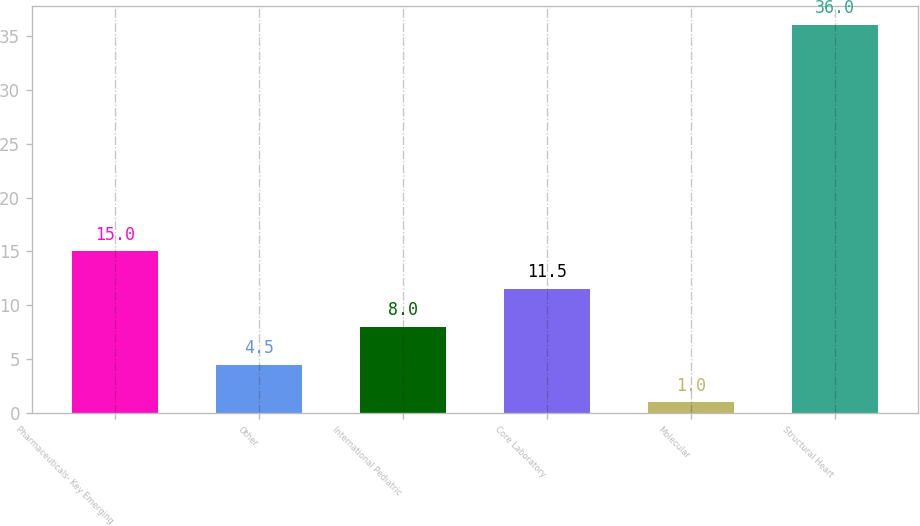<chart> <loc_0><loc_0><loc_500><loc_500><bar_chart><fcel>Pharmaceuticals- Key Emerging<fcel>Other<fcel>International Pediatric<fcel>Core Laboratory<fcel>Molecular<fcel>Structural Heart<nl><fcel>15<fcel>4.5<fcel>8<fcel>11.5<fcel>1<fcel>36<nl></chart> 